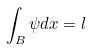<formula> <loc_0><loc_0><loc_500><loc_500>\int _ { B } \psi d x = l</formula> 